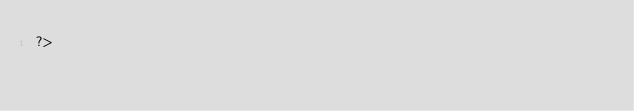Convert code to text. <code><loc_0><loc_0><loc_500><loc_500><_PHP_>?></code> 